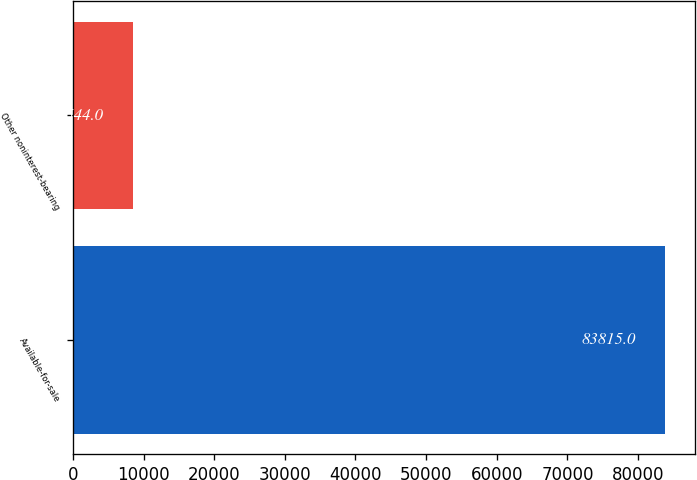Convert chart. <chart><loc_0><loc_0><loc_500><loc_500><bar_chart><fcel>Available-for-sale<fcel>Other noninterest-bearing<nl><fcel>83815<fcel>8544<nl></chart> 